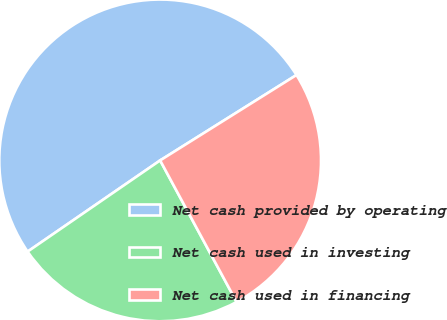Convert chart to OTSL. <chart><loc_0><loc_0><loc_500><loc_500><pie_chart><fcel>Net cash provided by operating<fcel>Net cash used in investing<fcel>Net cash used in financing<nl><fcel>50.69%<fcel>23.29%<fcel>26.03%<nl></chart> 